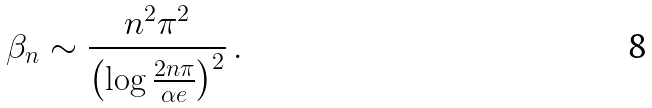<formula> <loc_0><loc_0><loc_500><loc_500>\beta _ { n } \sim \frac { n ^ { 2 } \pi ^ { 2 } } { \left ( \log \frac { 2 n \pi } { \alpha e } \right ) ^ { 2 } } \, .</formula> 